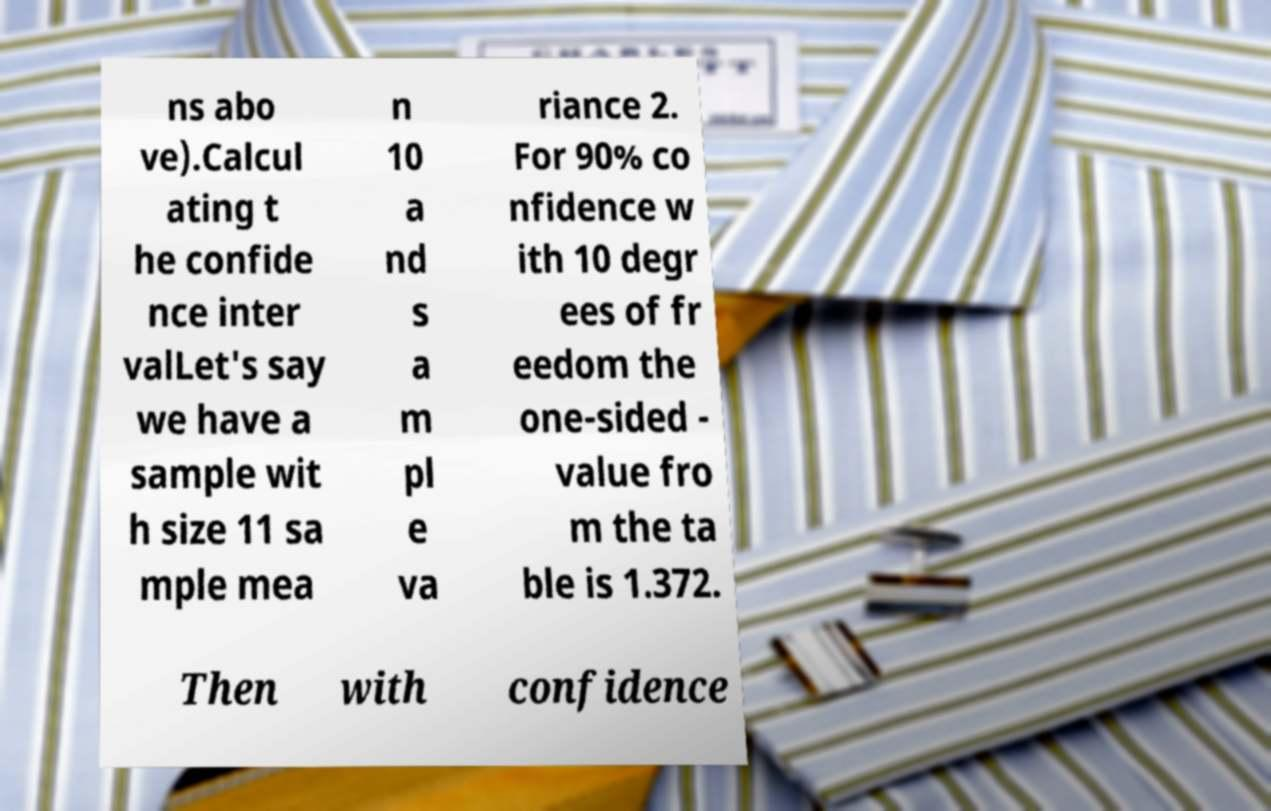I need the written content from this picture converted into text. Can you do that? ns abo ve).Calcul ating t he confide nce inter valLet's say we have a sample wit h size 11 sa mple mea n 10 a nd s a m pl e va riance 2. For 90% co nfidence w ith 10 degr ees of fr eedom the one-sided - value fro m the ta ble is 1.372. Then with confidence 